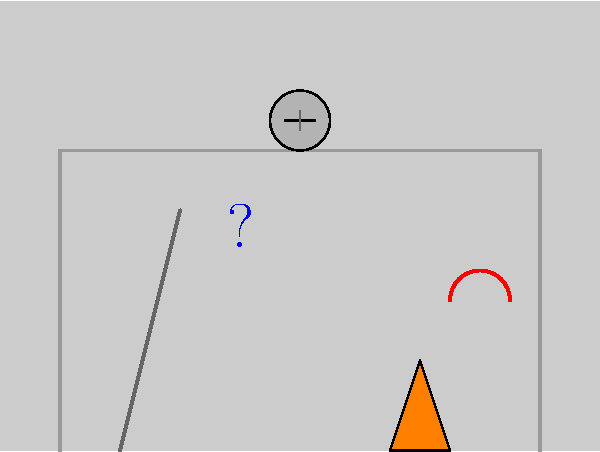What's the biggest danger in this picture? 1. Look at the worker: No hard hat on his head. That's risky, but not the worst.
2. Check the ladder: It's not tied or secured. Pretty dangerous, but still not the biggest threat.
3. Notice the orange cone: It's there to warn about something, but what?
4. Spot the red squiggly lines: Those are exposed electrical wires. Electricity can kill instantly.
5. Compare all hazards: Unsecured ladder and no helmet are bad, but exposed live wires are the deadliest.
Answer: Exposed electrical wires 